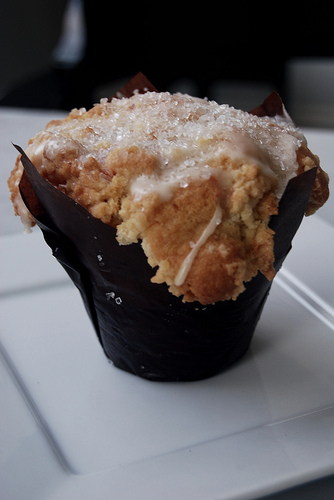<image>
Is the food in the table? No. The food is not contained within the table. These objects have a different spatial relationship. 